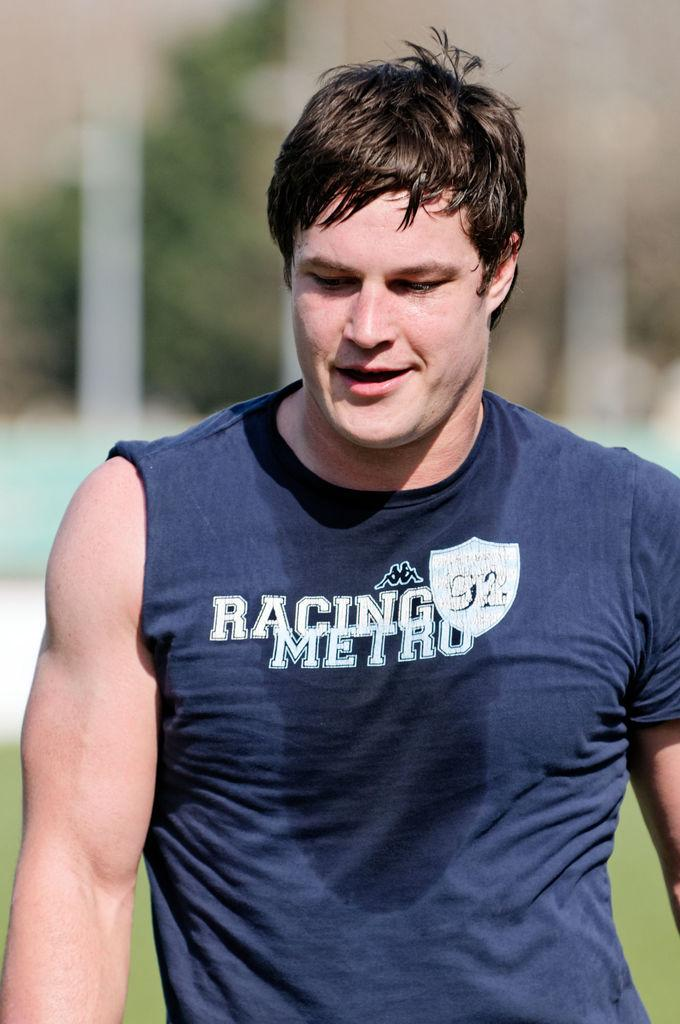<image>
Describe the image concisely. sweaty man in blue shirt that has racing metro written on it 